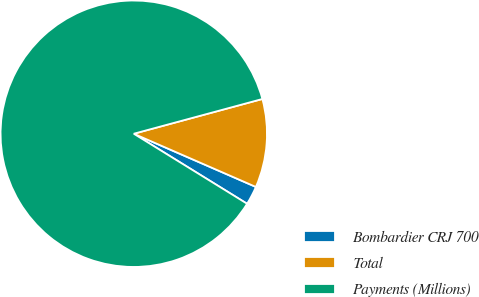Convert chart to OTSL. <chart><loc_0><loc_0><loc_500><loc_500><pie_chart><fcel>Bombardier CRJ 700<fcel>Total<fcel>Payments (Millions)<nl><fcel>2.27%<fcel>10.74%<fcel>86.99%<nl></chart> 